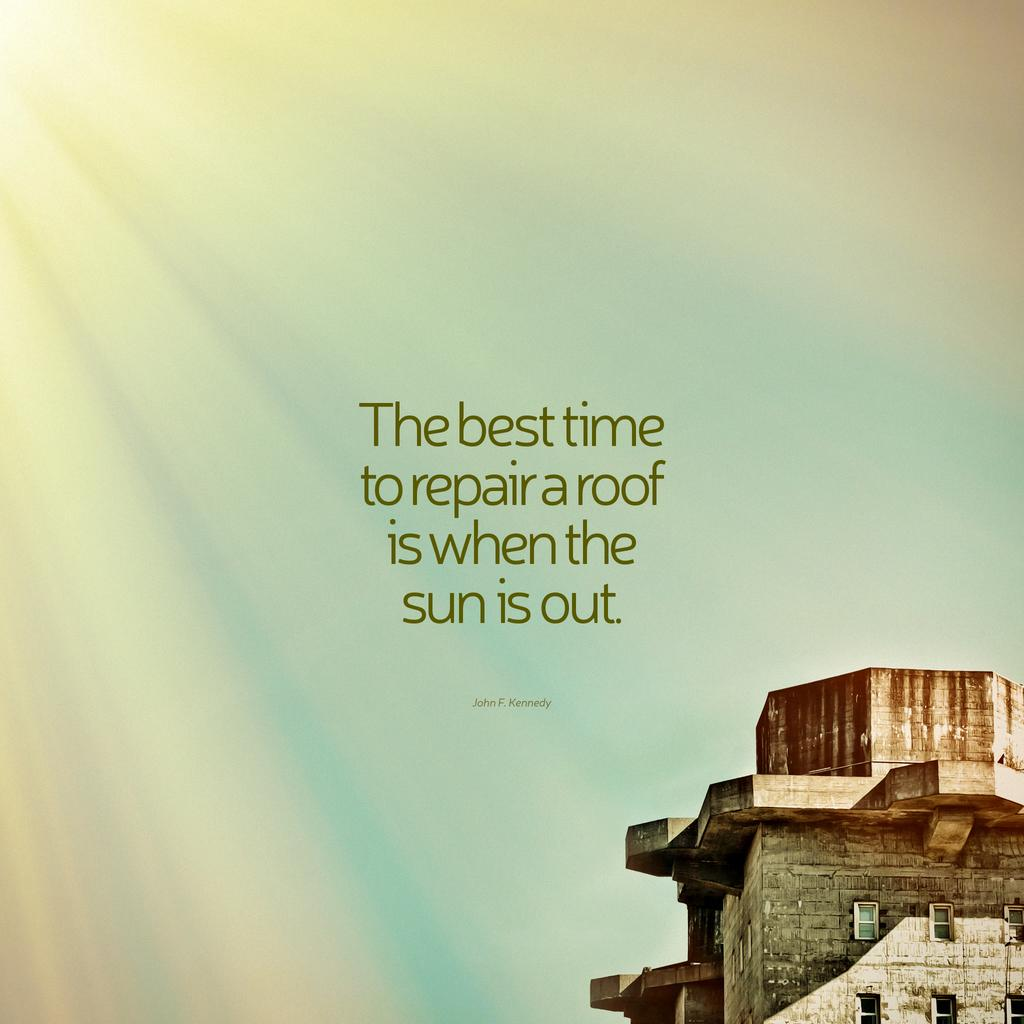What type of structure is in the image? There is a building in the image. What colors can be seen on the building? The building has brown and gray colors. What is visible in the background of the image? The sky is visible in the background of the image. What colors are present in the sky? The sky has blue and white colors. Is there any text or writing in the image? Yes, there is text or writing present in the image. Can you see any yaks in the image? There are no yaks present in the image. What type of horn is visible on the building in the image? There is no horn visible on the building in the image. 